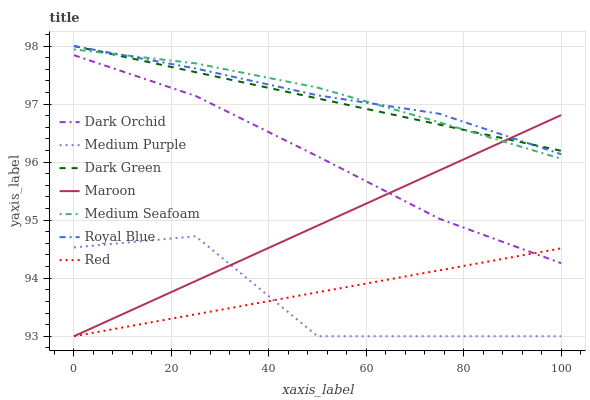Does Medium Purple have the minimum area under the curve?
Answer yes or no. Yes. Does Medium Seafoam have the maximum area under the curve?
Answer yes or no. Yes. Does Royal Blue have the minimum area under the curve?
Answer yes or no. No. Does Royal Blue have the maximum area under the curve?
Answer yes or no. No. Is Maroon the smoothest?
Answer yes or no. Yes. Is Medium Purple the roughest?
Answer yes or no. Yes. Is Royal Blue the smoothest?
Answer yes or no. No. Is Royal Blue the roughest?
Answer yes or no. No. Does Maroon have the lowest value?
Answer yes or no. Yes. Does Royal Blue have the lowest value?
Answer yes or no. No. Does Dark Green have the highest value?
Answer yes or no. Yes. Does Medium Purple have the highest value?
Answer yes or no. No. Is Medium Purple less than Dark Orchid?
Answer yes or no. Yes. Is Medium Seafoam greater than Red?
Answer yes or no. Yes. Does Medium Seafoam intersect Royal Blue?
Answer yes or no. Yes. Is Medium Seafoam less than Royal Blue?
Answer yes or no. No. Is Medium Seafoam greater than Royal Blue?
Answer yes or no. No. Does Medium Purple intersect Dark Orchid?
Answer yes or no. No. 